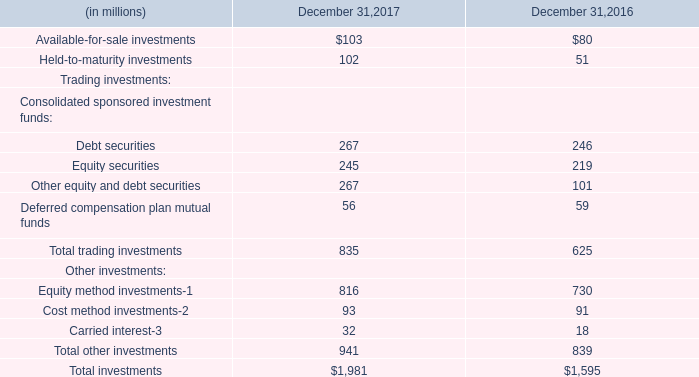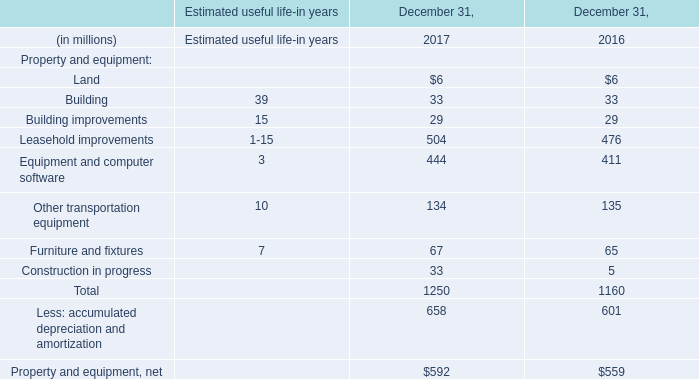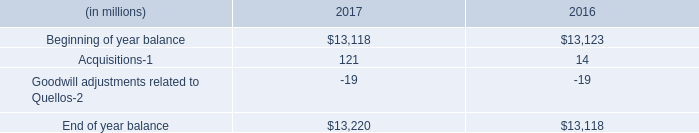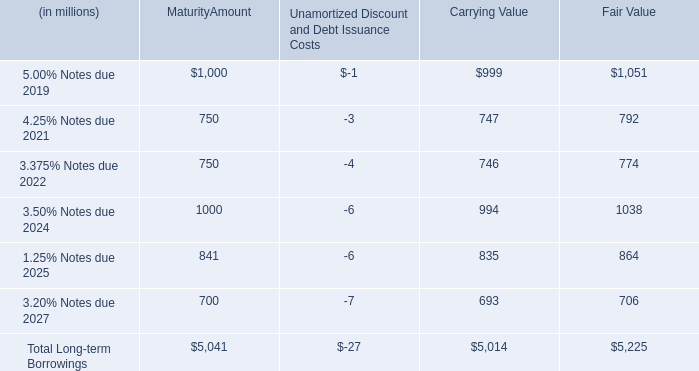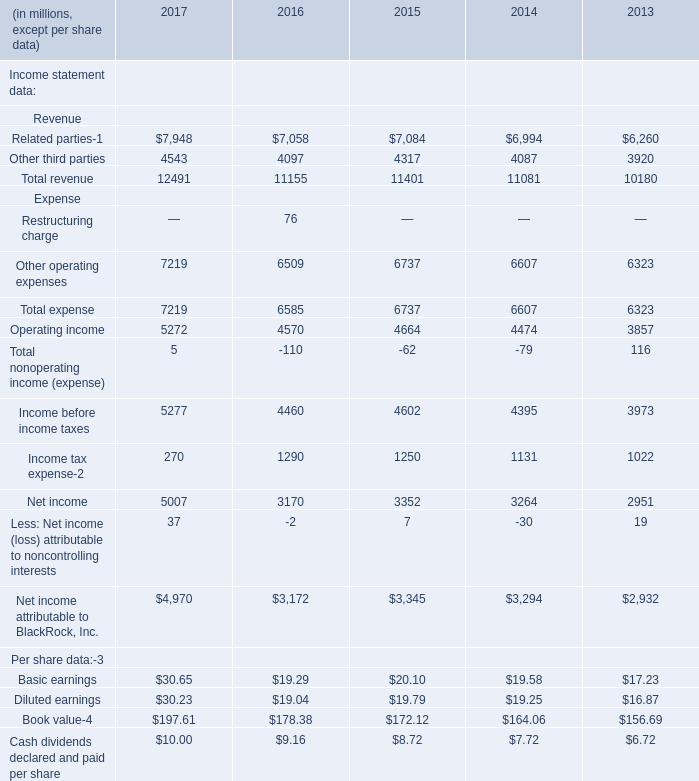what is the percentage change in the fair value of company's interest in pennymac from 2016 to 2017? 
Computations: ((348 - 259) / 259)
Answer: 0.34363. 